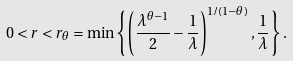Convert formula to latex. <formula><loc_0><loc_0><loc_500><loc_500>0 < r < r _ { \theta } = \min \left \{ \left ( \frac { \lambda ^ { \theta - 1 } } { 2 } - \frac { 1 } { \lambda } \right ) ^ { 1 / ( 1 - \theta ) } , \frac { 1 } { \lambda } \right \} .</formula> 